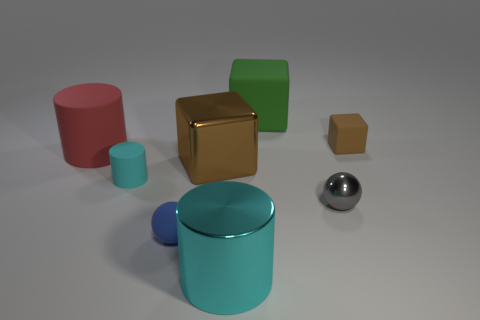Subtract all purple cylinders. Subtract all brown spheres. How many cylinders are left? 3 Add 1 small cyan matte cylinders. How many objects exist? 9 Subtract all spheres. How many objects are left? 6 Add 5 gray metallic things. How many gray metallic things are left? 6 Add 4 tiny yellow objects. How many tiny yellow objects exist? 4 Subtract 0 cyan spheres. How many objects are left? 8 Subtract all gray cylinders. Subtract all big shiny blocks. How many objects are left? 7 